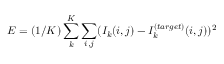Convert formula to latex. <formula><loc_0><loc_0><loc_500><loc_500>E = ( 1 / K ) \sum _ { k } ^ { K } \sum _ { i , j } ( I _ { k } ( i , j ) - I _ { k } ^ { ( t \arg e t ) } ( i , j ) ) ^ { 2 }</formula> 